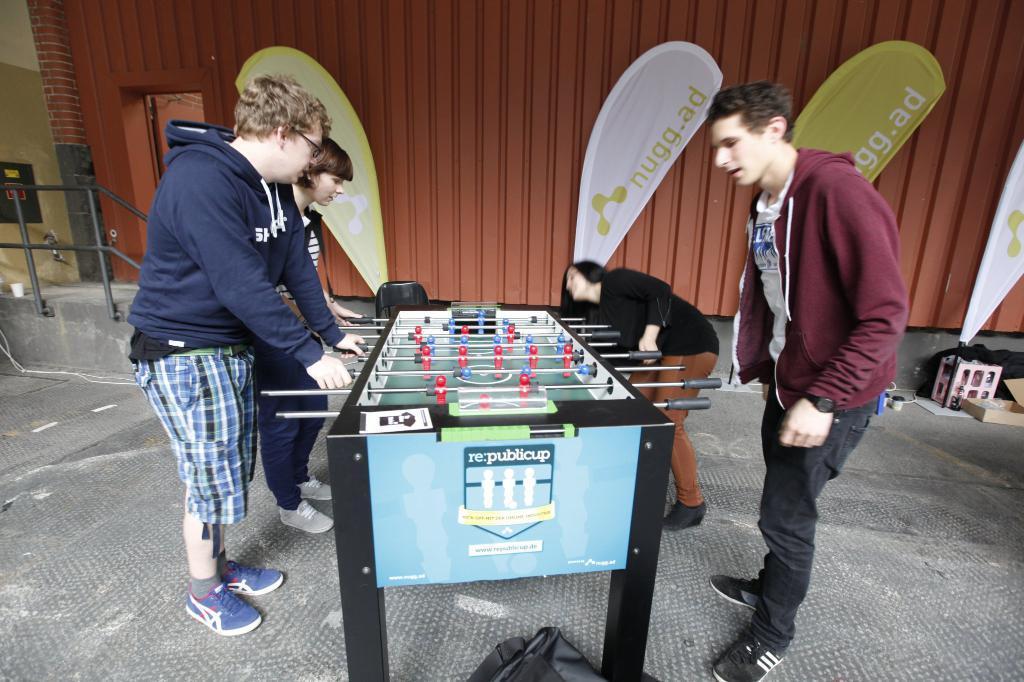How would you summarize this image in a sentence or two? In this image in the center there are four people standing, and they are playing some game. And in the center there is a table and some rods, and in the background there is wall, door, railing, box and some other objects. At the bottom there is floor and there is some object. 